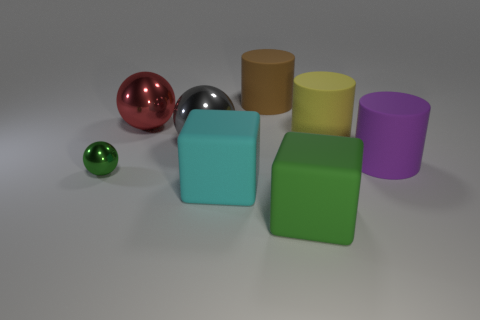Is there any other thing that is the same size as the green shiny object?
Offer a very short reply. No. What number of other large green blocks have the same material as the green cube?
Offer a very short reply. 0. What shape is the metallic object that is both behind the small ball and in front of the large red thing?
Offer a terse response. Sphere. Do the ball that is right of the red sphere and the brown cylinder have the same material?
Give a very brief answer. No. Is there any other thing that is the same material as the small green sphere?
Your response must be concise. Yes. What color is the other metal sphere that is the same size as the red sphere?
Keep it short and to the point. Gray. Is there a tiny block that has the same color as the tiny ball?
Your response must be concise. No. What is the size of the yellow cylinder that is made of the same material as the purple cylinder?
Keep it short and to the point. Large. What is the size of the other rubber object that is the same color as the small thing?
Your response must be concise. Large. What number of other things are there of the same size as the brown rubber cylinder?
Your answer should be compact. 6. 